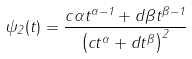Convert formula to latex. <formula><loc_0><loc_0><loc_500><loc_500>\psi _ { 2 } ( t ) = \frac { c \alpha t ^ { \alpha - 1 } + d \beta t ^ { \beta - 1 } } { \left ( c t ^ { \alpha } + d t ^ { \beta } \right ) ^ { 2 } }</formula> 